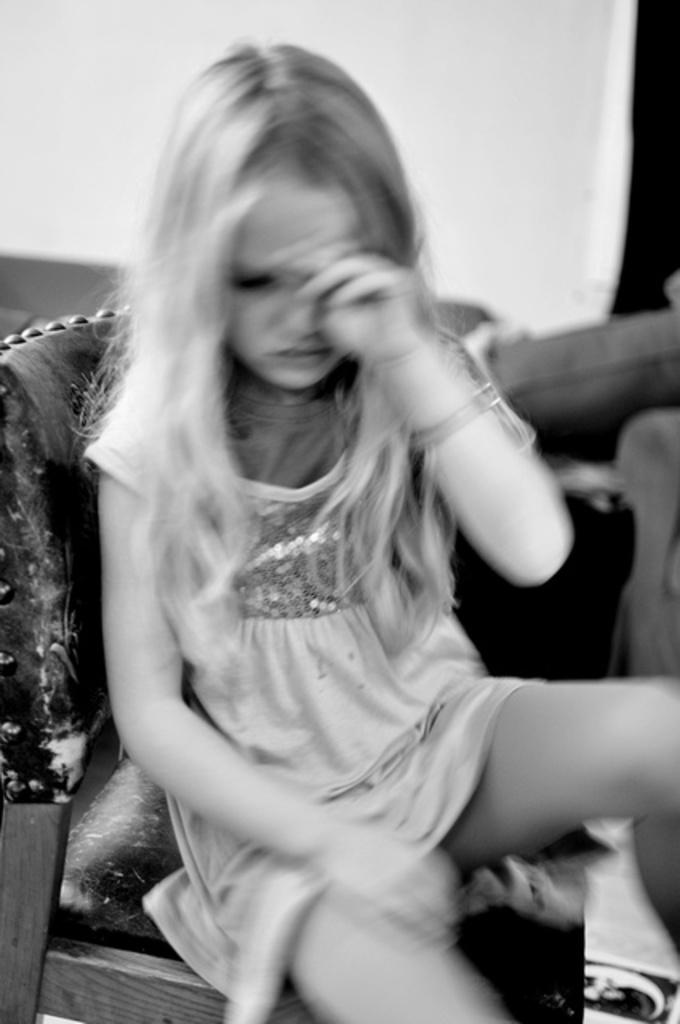What is the main subject of the image? The main subject of the image is a child. What is the child doing in the image? The child is sitting on a chair and crying. What type of fuel is the child using to power their crying in the image? The child is not using any fuel to power their crying in the image; they are simply crying. What type of juice can be seen in the image? There is no juice present in the image. 